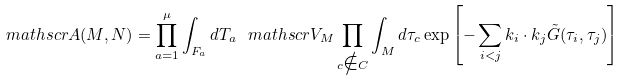<formula> <loc_0><loc_0><loc_500><loc_500>\ m a t h s c r { A } ( M , N ) = \prod _ { a = 1 } ^ { \mu } \int _ { F _ { a } } d T _ { a } \, \ m a t h s c r { V } _ { M } \prod _ { c \notin C } \int _ { M } d \tau _ { c } \exp \left [ - \sum _ { i < j } k _ { i } \cdot k _ { j } \tilde { G } ( \tau _ { i } , \tau _ { j } ) \right ]</formula> 